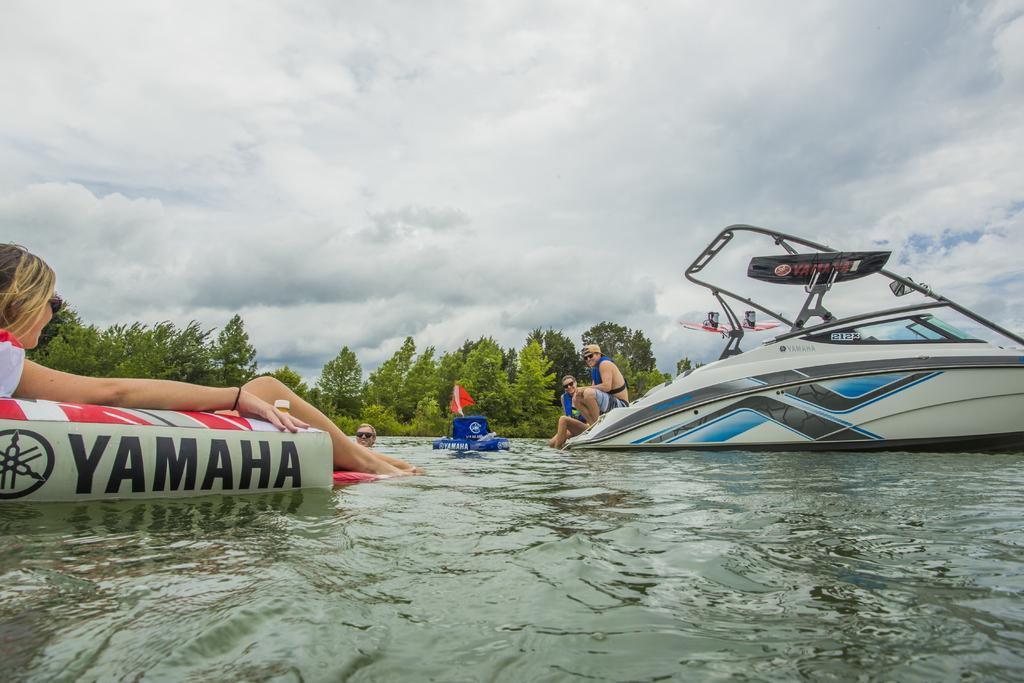Could you give a brief overview of what you see in this image? On the left side of the image, we can see a woman on the inflatable object. In the middle of the image, we can see two persons, inflatable object and a person in the water. On the right side of the image, there is a boat on the water. In the background, there are trees, plants and the cloudy sky. 